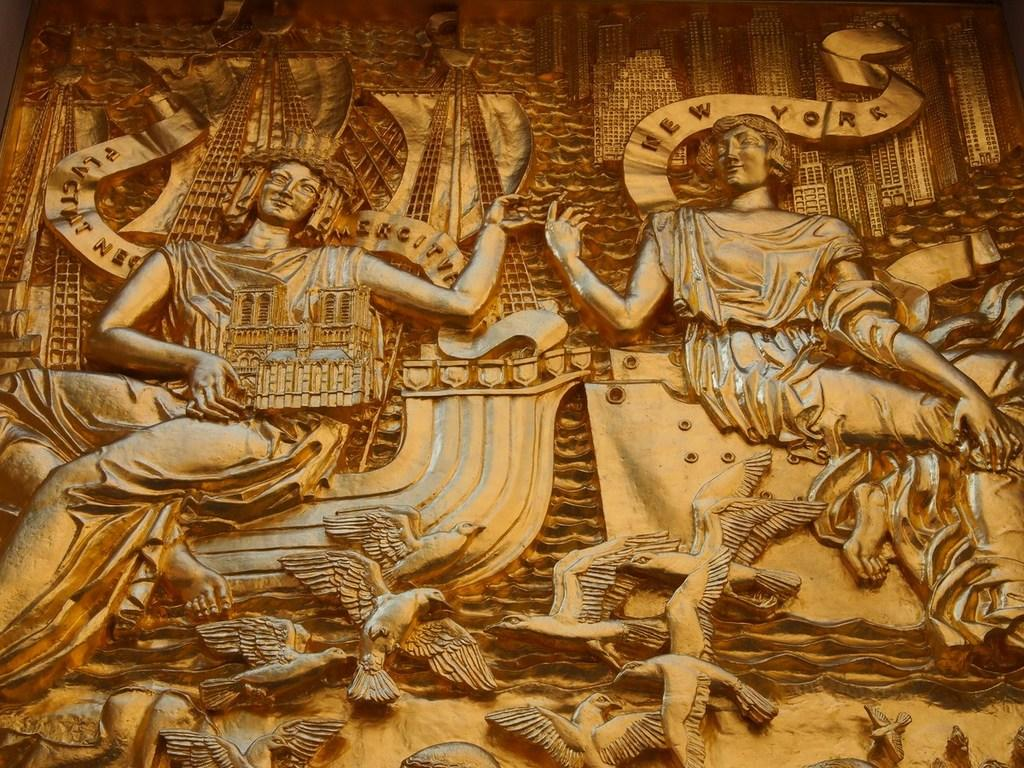What type of artwork is depicted on the wall in the image? There are carvings of persons, birds, and buildings on the wall in the image. What color are the carvings on the wall? The carvings are in brown color. Can you tell me how many wounds are visible on the persons in the carvings? There are no wounds visible on the persons in the carvings, as the carvings depict people and not injuries. What type of rock is the carving made of? The provided facts do not mention the material used for the carvings, so it cannot be determined from the image. 